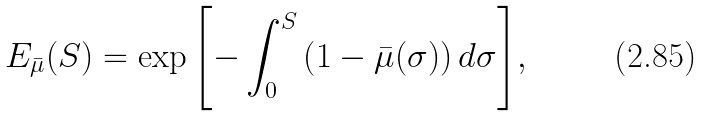Convert formula to latex. <formula><loc_0><loc_0><loc_500><loc_500>E _ { \bar { \mu } } ( S ) = \exp { \left [ - \int _ { 0 } ^ { S } \left ( 1 - \bar { \mu } ( \sigma ) \right ) d \sigma \right ] } ,</formula> 